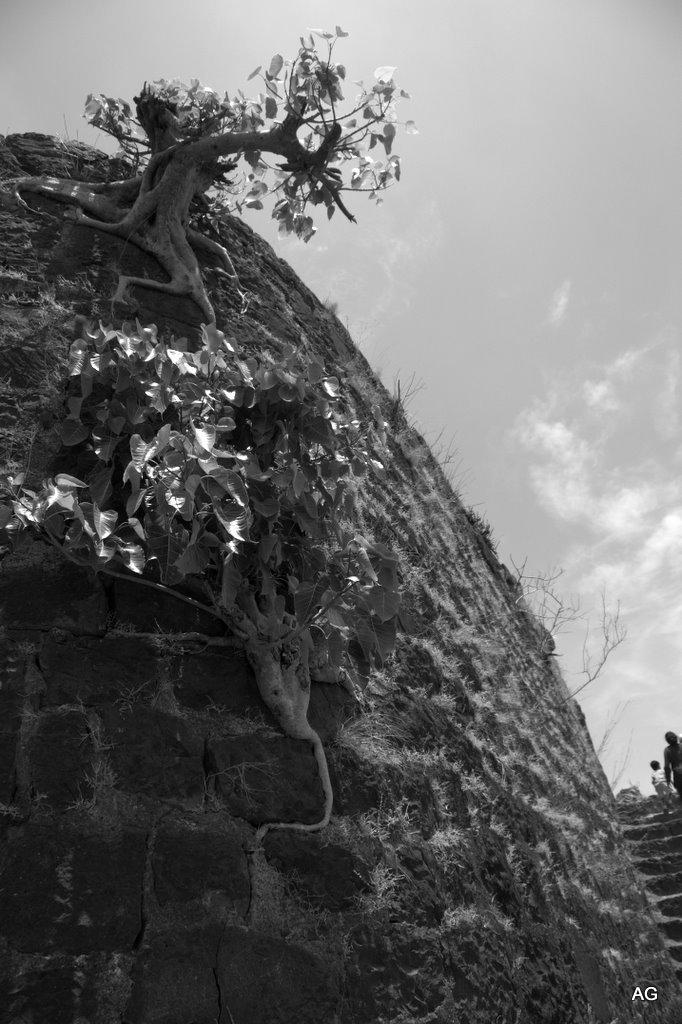What is the color scheme of the image? The image is black and white. What can be seen on the wall in the image? There are trees on the wall in the image. What is visible at the top of the image? The sky is visible at the top of the image. How many people are in the image? There are two people in the image. Where are the people located in the image? The people are on the right side of the image. What architectural feature is present in the image? There are stairs in the image. What type of map can be seen on the wall in the image? There is no map present on the wall in the image; it features trees instead. What color is the collar of the dog in the image? There is no dog, and therefore no collar, present in the image. 